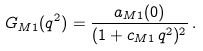Convert formula to latex. <formula><loc_0><loc_0><loc_500><loc_500>G _ { M 1 } ( q ^ { 2 } ) = \frac { a _ { M 1 } ( 0 ) } { ( 1 + c _ { M 1 } \, q ^ { 2 } ) ^ { 2 } } \, .</formula> 